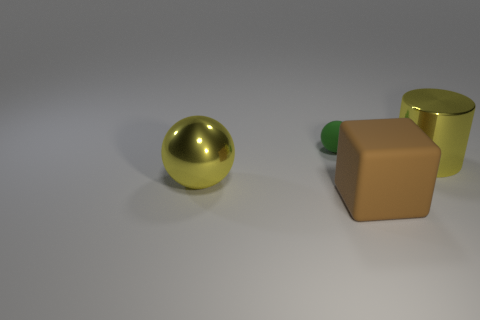Do the big cube and the sphere that is behind the big yellow metal ball have the same color?
Give a very brief answer. No. There is a green thing that is made of the same material as the large brown object; what is its shape?
Offer a terse response. Sphere. How many small purple matte balls are there?
Your answer should be very brief. 0. How many things are spheres behind the big yellow ball or tiny green balls?
Your answer should be compact. 1. There is a metal thing to the left of the yellow shiny cylinder; is it the same color as the big metallic cylinder?
Your answer should be very brief. Yes. What number of other objects are the same color as the large block?
Your answer should be very brief. 0. How many tiny things are either yellow cylinders or red rubber cylinders?
Your answer should be very brief. 0. Are there more tiny brown blocks than big matte objects?
Give a very brief answer. No. Is the material of the tiny green sphere the same as the large sphere?
Ensure brevity in your answer.  No. Are there any other things that have the same material as the small green object?
Provide a short and direct response. Yes. 